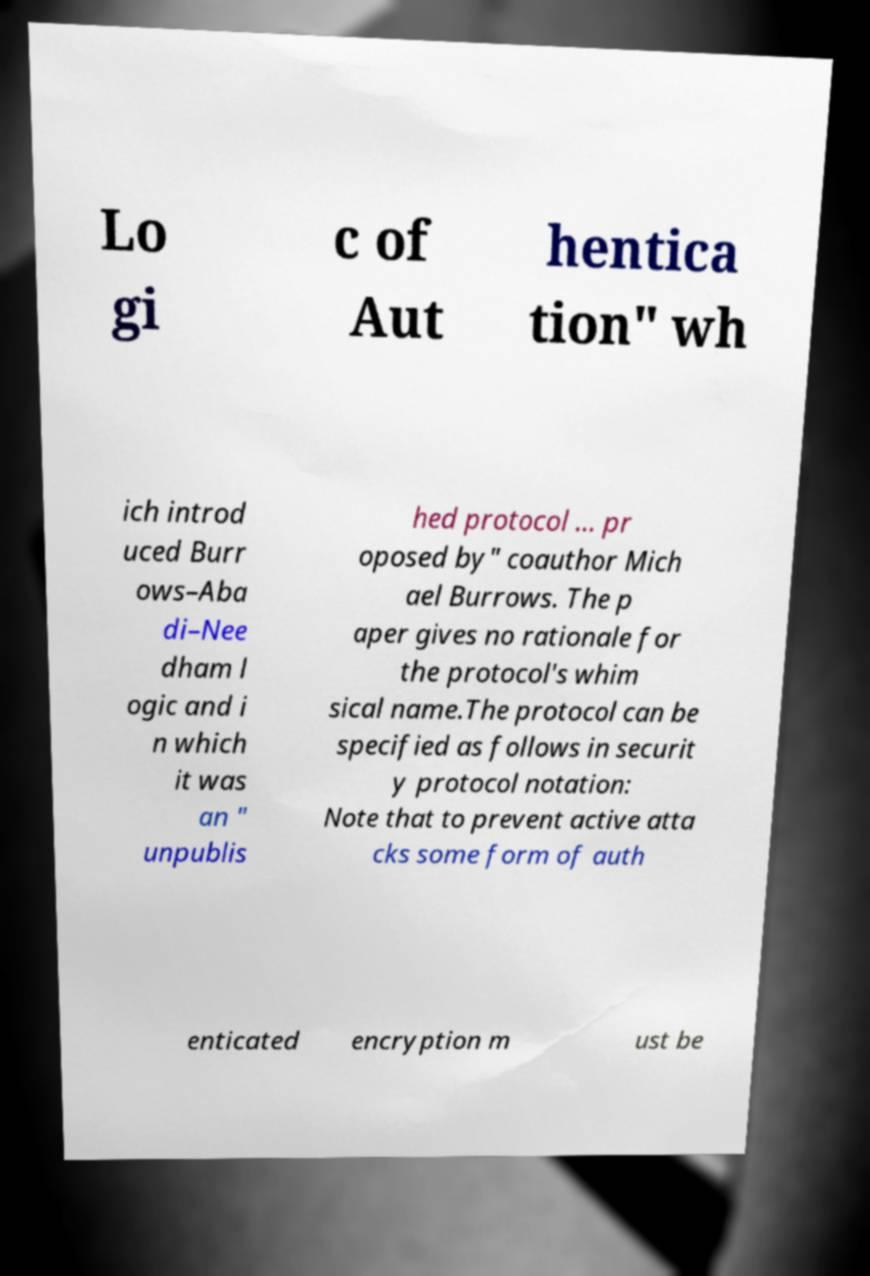Please read and relay the text visible in this image. What does it say? Lo gi c of Aut hentica tion" wh ich introd uced Burr ows–Aba di–Nee dham l ogic and i n which it was an " unpublis hed protocol ... pr oposed by" coauthor Mich ael Burrows. The p aper gives no rationale for the protocol's whim sical name.The protocol can be specified as follows in securit y protocol notation: Note that to prevent active atta cks some form of auth enticated encryption m ust be 